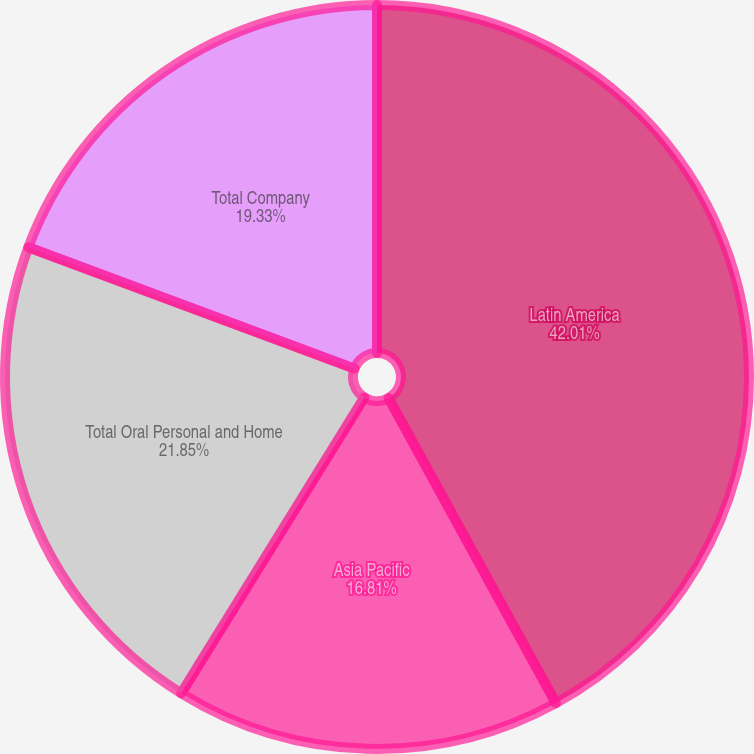<chart> <loc_0><loc_0><loc_500><loc_500><pie_chart><fcel>Latin America<fcel>Asia Pacific<fcel>Total Oral Personal and Home<fcel>Total Company<nl><fcel>42.02%<fcel>16.81%<fcel>21.85%<fcel>19.33%<nl></chart> 